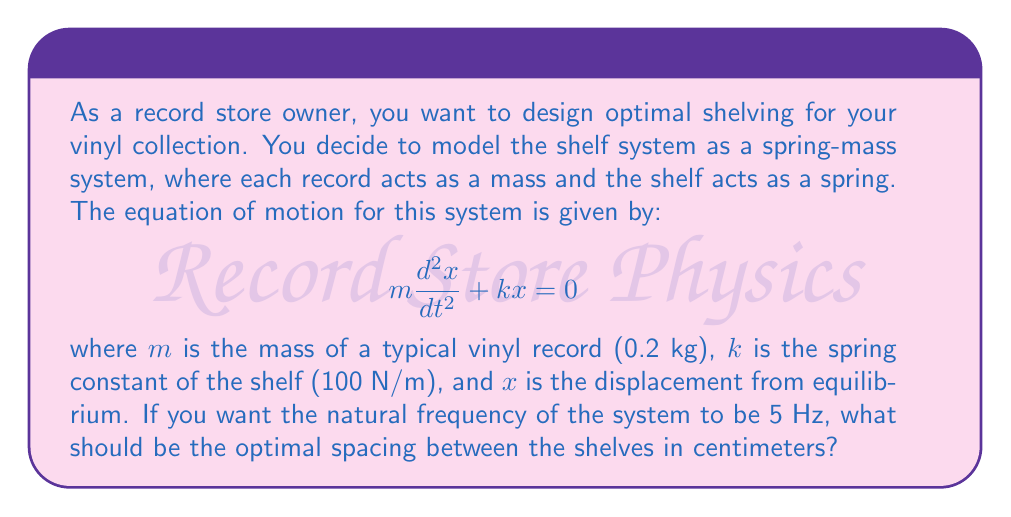Show me your answer to this math problem. To solve this problem, we'll follow these steps:

1) The natural frequency of a spring-mass system is given by:

   $$f = \frac{1}{2\pi}\sqrt{\frac{k}{m}}$$

2) We're given that $f = 5$ Hz, $k = 100$ N/m, and $m = 0.2$ kg. Let's substitute these values:

   $$5 = \frac{1}{2\pi}\sqrt{\frac{100}{0.2}}$$

3) Now, let's solve for the right side of the equation:

   $$5 = \frac{1}{2\pi}\sqrt{500} = \frac{\sqrt{500}}{2\pi} \approx 3.56$$

4) This doesn't match our desired frequency of 5 Hz. To achieve this frequency, we need to adjust the spring constant $k$. Let's solve for $k$:

   $$5 = \frac{1}{2\pi}\sqrt{\frac{k}{0.2}}$$
   $$(5 \cdot 2\pi)^2 = \frac{k}{0.2}$$
   $$k = 0.2 \cdot (5 \cdot 2\pi)^2 \approx 197.4 \text{ N/m}$$

5) Now that we have the correct spring constant, we can calculate the displacement. The spring force is given by $F = kx$, where $x$ is the displacement. The weight of the record provides the force: $F = mg$, where $g$ is the acceleration due to gravity (9.8 m/s²).

6) Setting these equal:

   $$kx = mg$$
   $$197.4x = 0.2 \cdot 9.8$$
   $$x = \frac{0.2 \cdot 9.8}{197.4} \approx 0.00993 \text{ m}$$

7) Convert this to centimeters:

   $$x \approx 0.00993 \text{ m} \cdot \frac{100 \text{ cm}}{1 \text{ m}} = 0.993 \text{ cm}$$

Therefore, the optimal spacing between the shelves should be approximately 0.993 cm.
Answer: The optimal spacing between the shelves should be approximately 0.993 cm. 